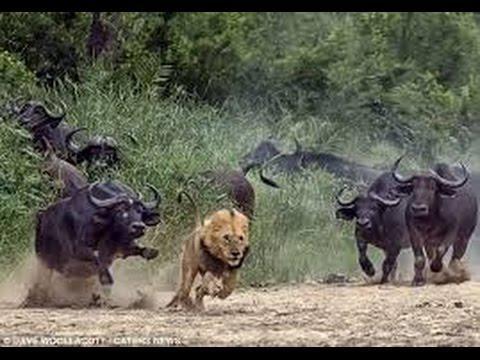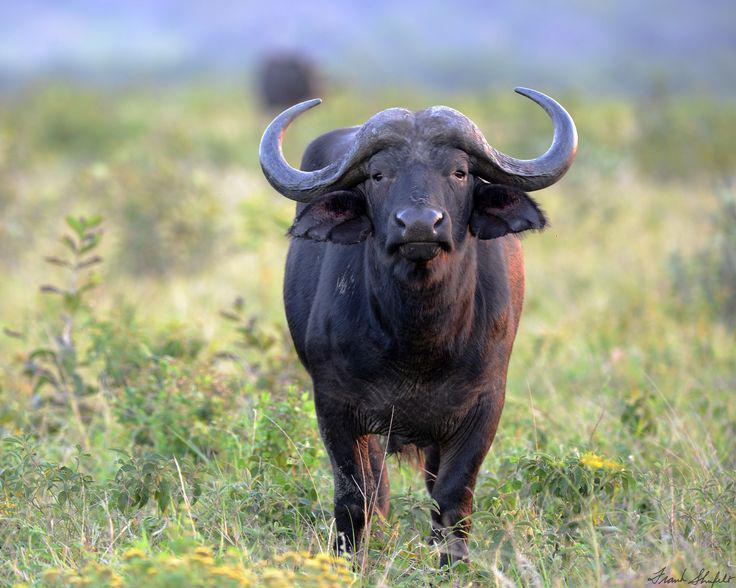The first image is the image on the left, the second image is the image on the right. Assess this claim about the two images: "An action scene with a water buffalo features a maned lion.". Correct or not? Answer yes or no. Yes. The first image is the image on the left, the second image is the image on the right. Assess this claim about the two images: "One image is an action scene involving at least one water buffalo and one lion, while the other image is a single water buffalo facing forward.". Correct or not? Answer yes or no. Yes. 